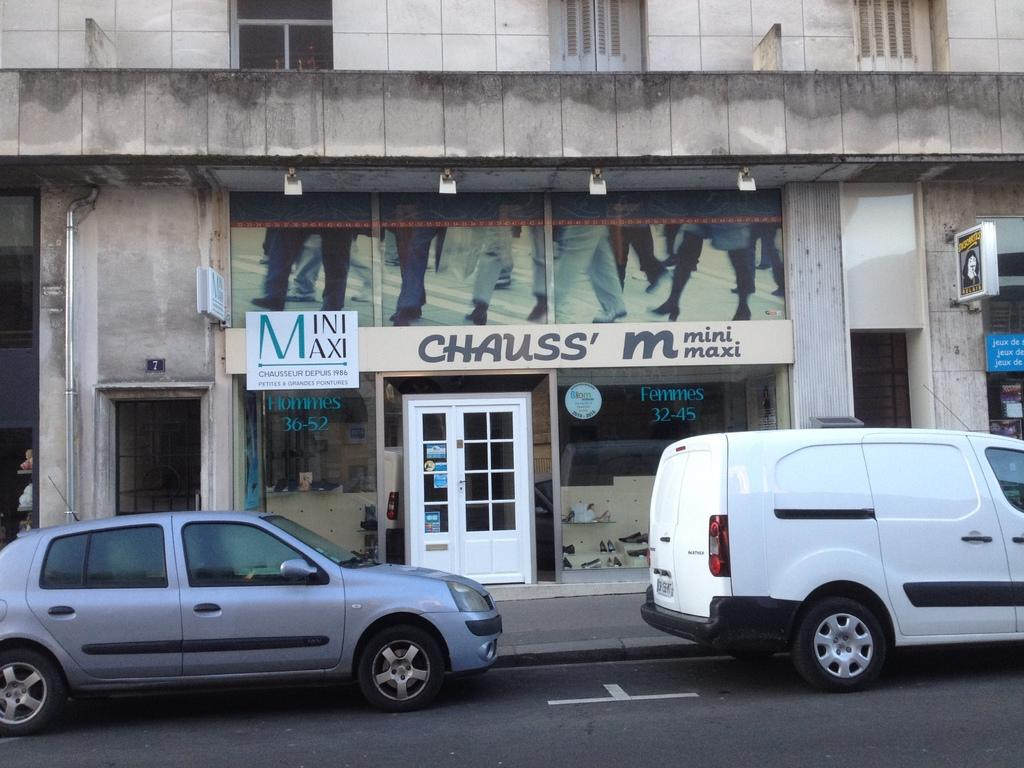What can be seen in the foreground of the picture? There are vehicles on the road in the foreground of the picture. What is located in the center of the picture? There are buildings, boards, lights, a pavement, and doors in the center of the picture. What architectural features can be seen at the top of the picture? There are windows visible at the top of the picture. What type of button can be seen on the tongue of the person in the picture? There is no person or tongue present in the picture; it features vehicles, buildings, and other inanimate objects. How does the pollution affect the buildings in the picture? There is no mention of pollution in the provided facts, and therefore we cannot determine its effect on the buildings in the picture. 